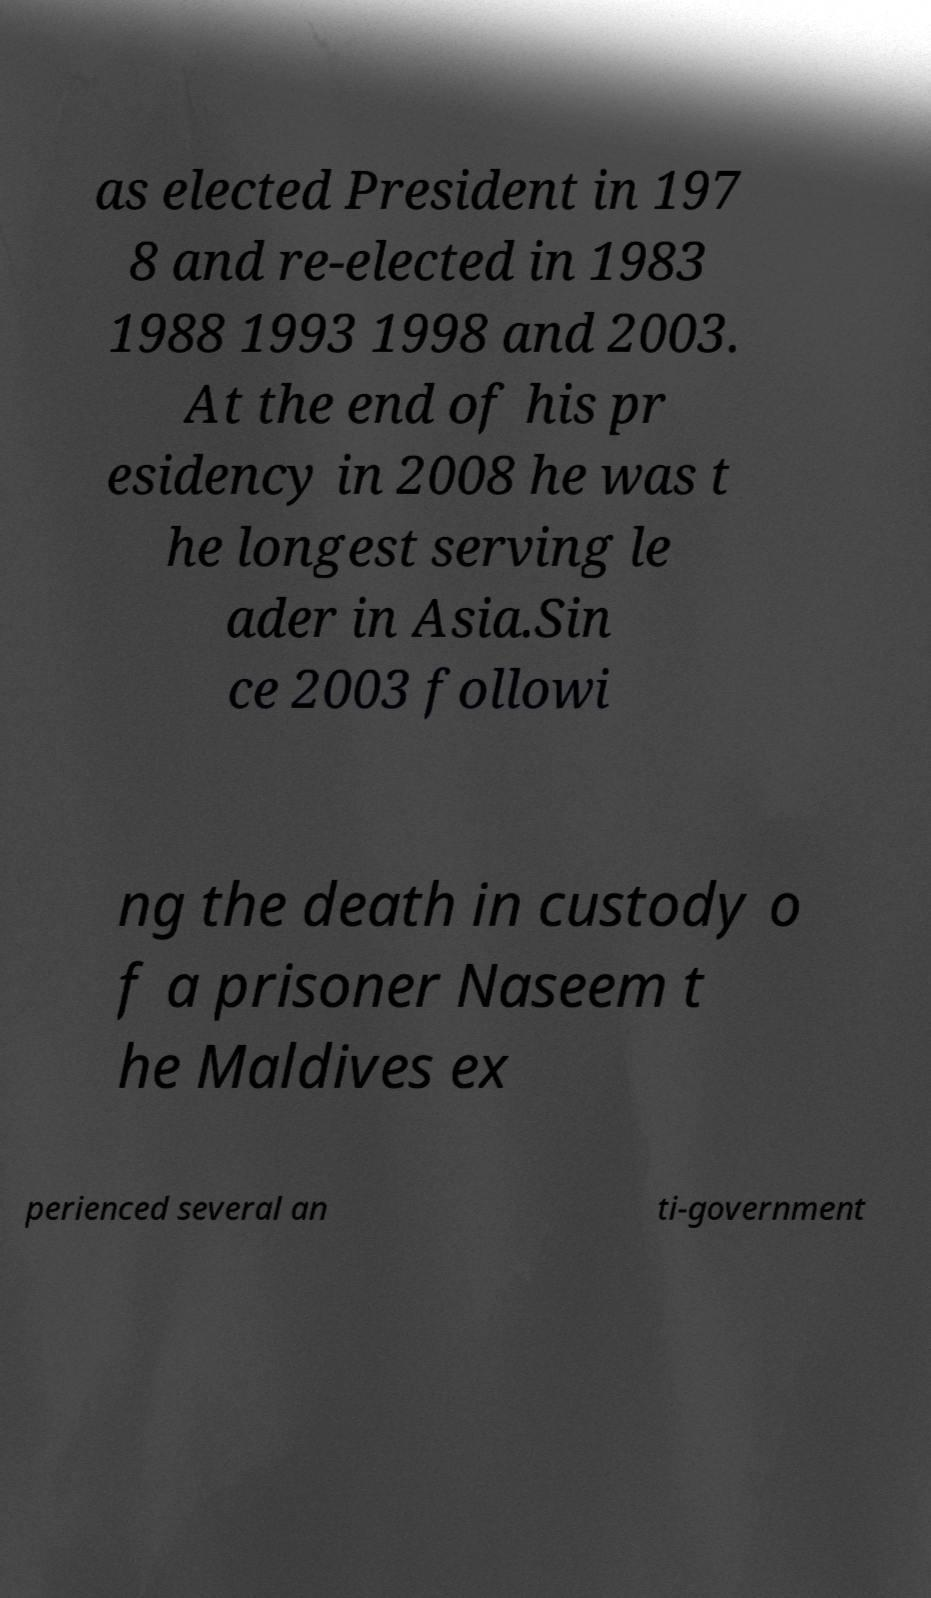Can you read and provide the text displayed in the image?This photo seems to have some interesting text. Can you extract and type it out for me? as elected President in 197 8 and re-elected in 1983 1988 1993 1998 and 2003. At the end of his pr esidency in 2008 he was t he longest serving le ader in Asia.Sin ce 2003 followi ng the death in custody o f a prisoner Naseem t he Maldives ex perienced several an ti-government 